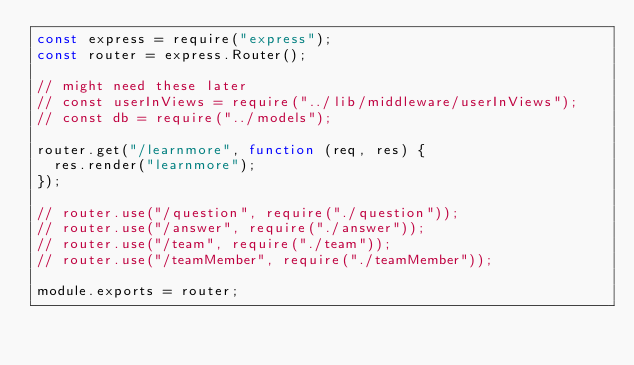Convert code to text. <code><loc_0><loc_0><loc_500><loc_500><_JavaScript_>const express = require("express");
const router = express.Router();

// might need these later
// const userInViews = require("../lib/middleware/userInViews");
// const db = require("../models");

router.get("/learnmore", function (req, res) {
  res.render("learnmore");
});

// router.use("/question", require("./question"));
// router.use("/answer", require("./answer"));
// router.use("/team", require("./team"));
// router.use("/teamMember", require("./teamMember"));

module.exports = router;</code> 